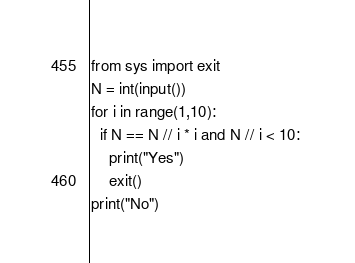<code> <loc_0><loc_0><loc_500><loc_500><_Python_>from sys import exit
N = int(input())
for i in range(1,10):
  if N == N // i * i and N // i < 10: 
    print("Yes")
    exit()
print("No")  </code> 